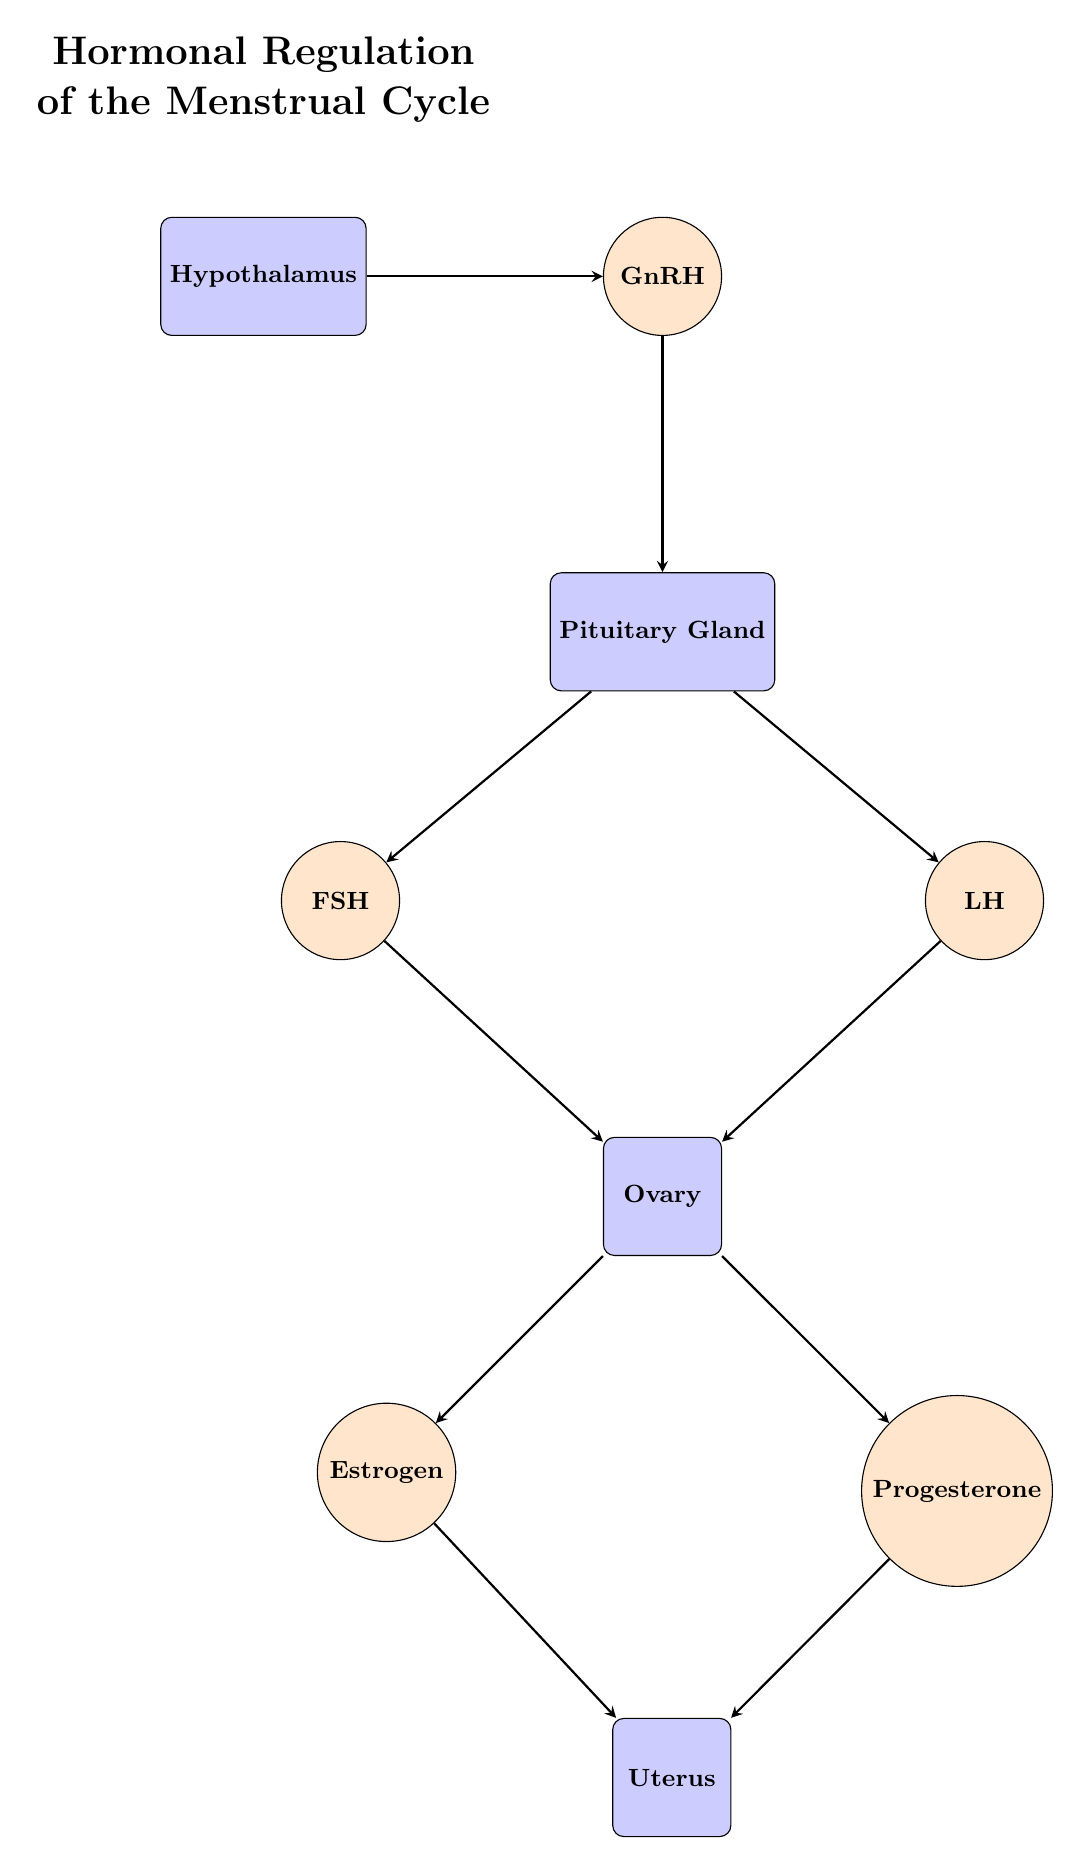What is the total number of nodes in the diagram? The diagram consists of several distinct elements representing various components in the hormonal regulation of the menstrual cycle. Counting each unique component (Hypothalamus, GnRH, Pituitary Gland, FSH, LH, Ovary, Estrogen, Progesterone, Uterus), we find there are 9 nodes in total.
Answer: 9 Which hormone directly connects the Hypothalamus and the Pituitary Gland? In the diagram, an arrow is shown leading from the Hypothalamus to GnRH, which then leads to the Pituitary Gland. Thus, GnRH is the hormone that acts as the intermediary between these two components.
Answer: GnRH How many hormones are produced by the Ovary? The Ovary produces two different hormones in this diagram as indicated by the arrows pointing from the Ovary to Estrogen and Progesterone. Therefore, the count of hormones produced by the Ovary is 2.
Answer: 2 What is the relationship between FSH and the Ovary? The diagram shows an arrow connecting FSH directly to the Ovary, indicating that FSH stimulates or has an effect on the Ovary. Therefore, the relationship can be described as stimulation.
Answer: Stimulates Which organ receives signals from both Estrogen and Progesterone? Analyzing the flows in the diagram, both Estrogen and Progesterone have arrows pointing toward the Uterus. This means the Uterus responds to signals from both of these hormones, thus making it the organ that receives signals from them.
Answer: Uterus Which gland releases FSH and LH? Observing the connections in the diagram, both FSH and LH are shown to originate from the Pituitary Gland. This indicates that the Pituitary Gland is responsible for the release of these hormones.
Answer: Pituitary Gland If GnRH is increased, which hormones would likely see an increase in their release? Following the diagram's flow, an increase in GnRH would stimulate the Pituitary Gland to release both FSH and LH. This results in both of these hormones likely seeing an increase in their levels due to the direct connection from GnRH to the Pituitary Gland.
Answer: FSH and LH What number of edges connect hormones to the Uterus? The diagram displays arrows from Estrogen and Progesterone leading directly to the Uterus. Counting these edges gives a total of 2 edges connecting hormones to the Uterus.
Answer: 2 Which hormone is linked to the Uterus via Estrogen? In the diagram, Estrogen is pointed towards the Uterus with an arrow, indicating that Estrogen has a role in signaling or regulating the Uterus. This makes Estrogen the hormone linked to the Uterus through direct connection.
Answer: Estrogen 